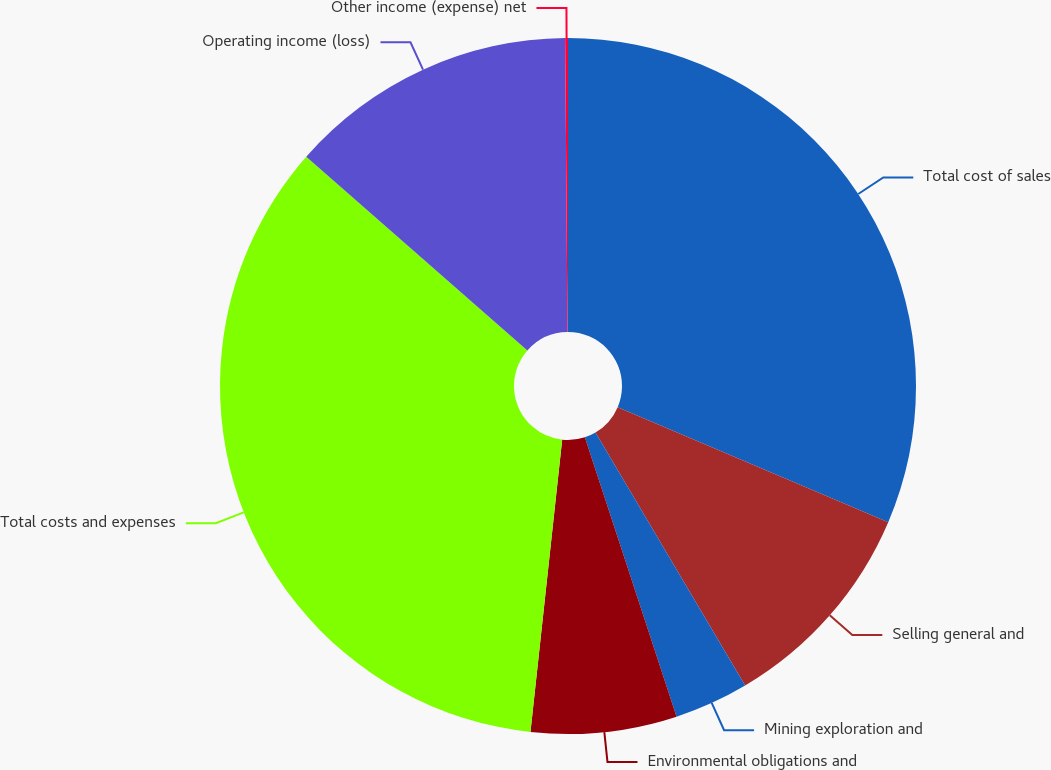Convert chart. <chart><loc_0><loc_0><loc_500><loc_500><pie_chart><fcel>Total cost of sales<fcel>Selling general and<fcel>Mining exploration and<fcel>Environmental obligations and<fcel>Total costs and expenses<fcel>Operating income (loss)<fcel>Other income (expense) net<nl><fcel>31.4%<fcel>10.1%<fcel>3.45%<fcel>6.77%<fcel>34.73%<fcel>13.42%<fcel>0.13%<nl></chart> 